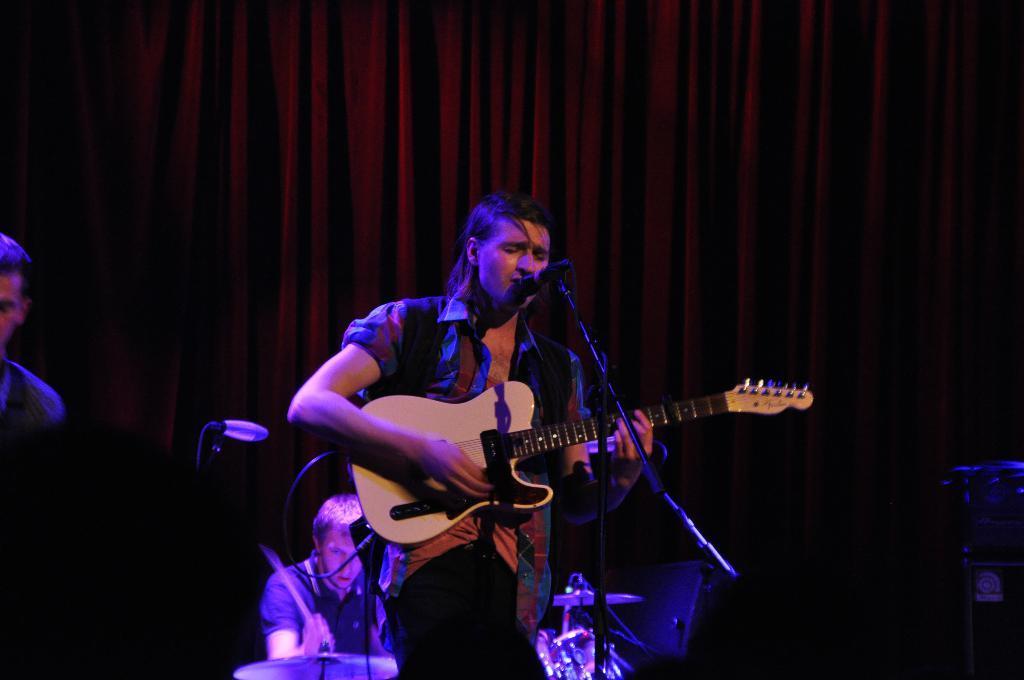Could you give a brief overview of what you see in this image? In this image there is one person who is standing and he is holding a guitar in front of him there is one mike it seems that he is singing. On the background there is one person who is drumming in front of him there are drums. On the left side there is one person on the background there is one cloth. 